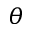<formula> <loc_0><loc_0><loc_500><loc_500>\theta</formula> 